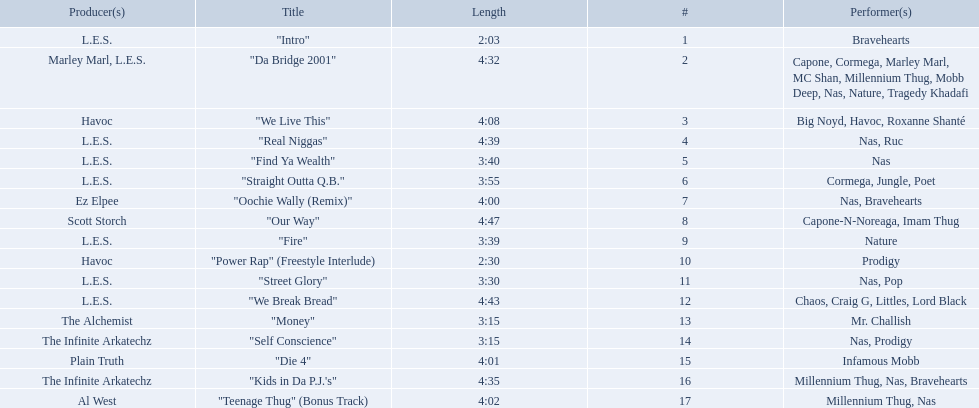What are all the songs on the album? "Intro", "Da Bridge 2001", "We Live This", "Real Niggas", "Find Ya Wealth", "Straight Outta Q.B.", "Oochie Wally (Remix)", "Our Way", "Fire", "Power Rap" (Freestyle Interlude), "Street Glory", "We Break Bread", "Money", "Self Conscience", "Die 4", "Kids in Da P.J.'s", "Teenage Thug" (Bonus Track). Which is the shortest? "Intro". How long is that song? 2:03. 